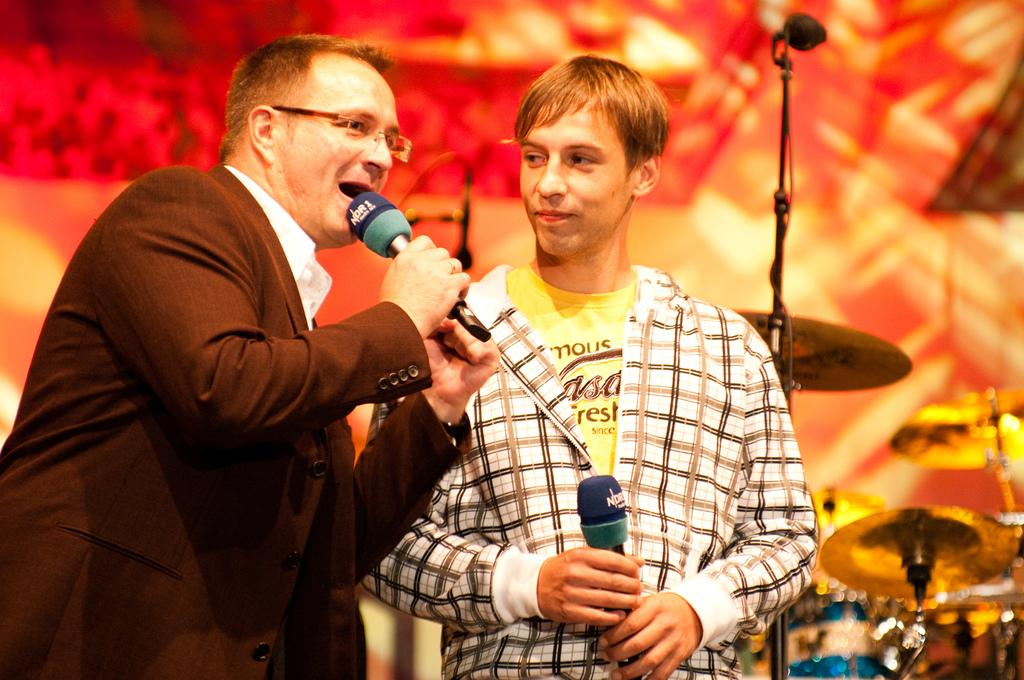Who is the main subject in the image? There is a man in the image. What is the man holding in his hand? The man is holding a mic in his hand. Who else is present in the image? There is a boy in the image. What is the boy doing in the image? The boy is standing beside the man and holding a mic. What type of cannon is being used to shoot lead paste in the image? There is no cannon or lead paste present in the image. 